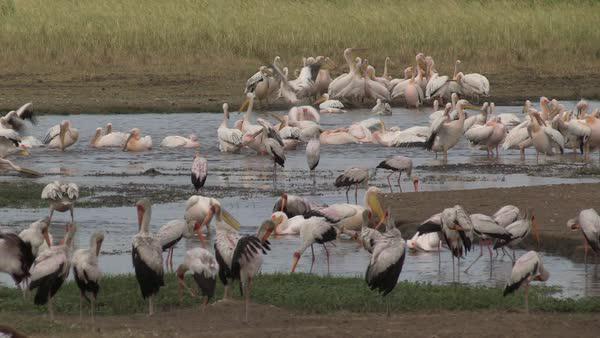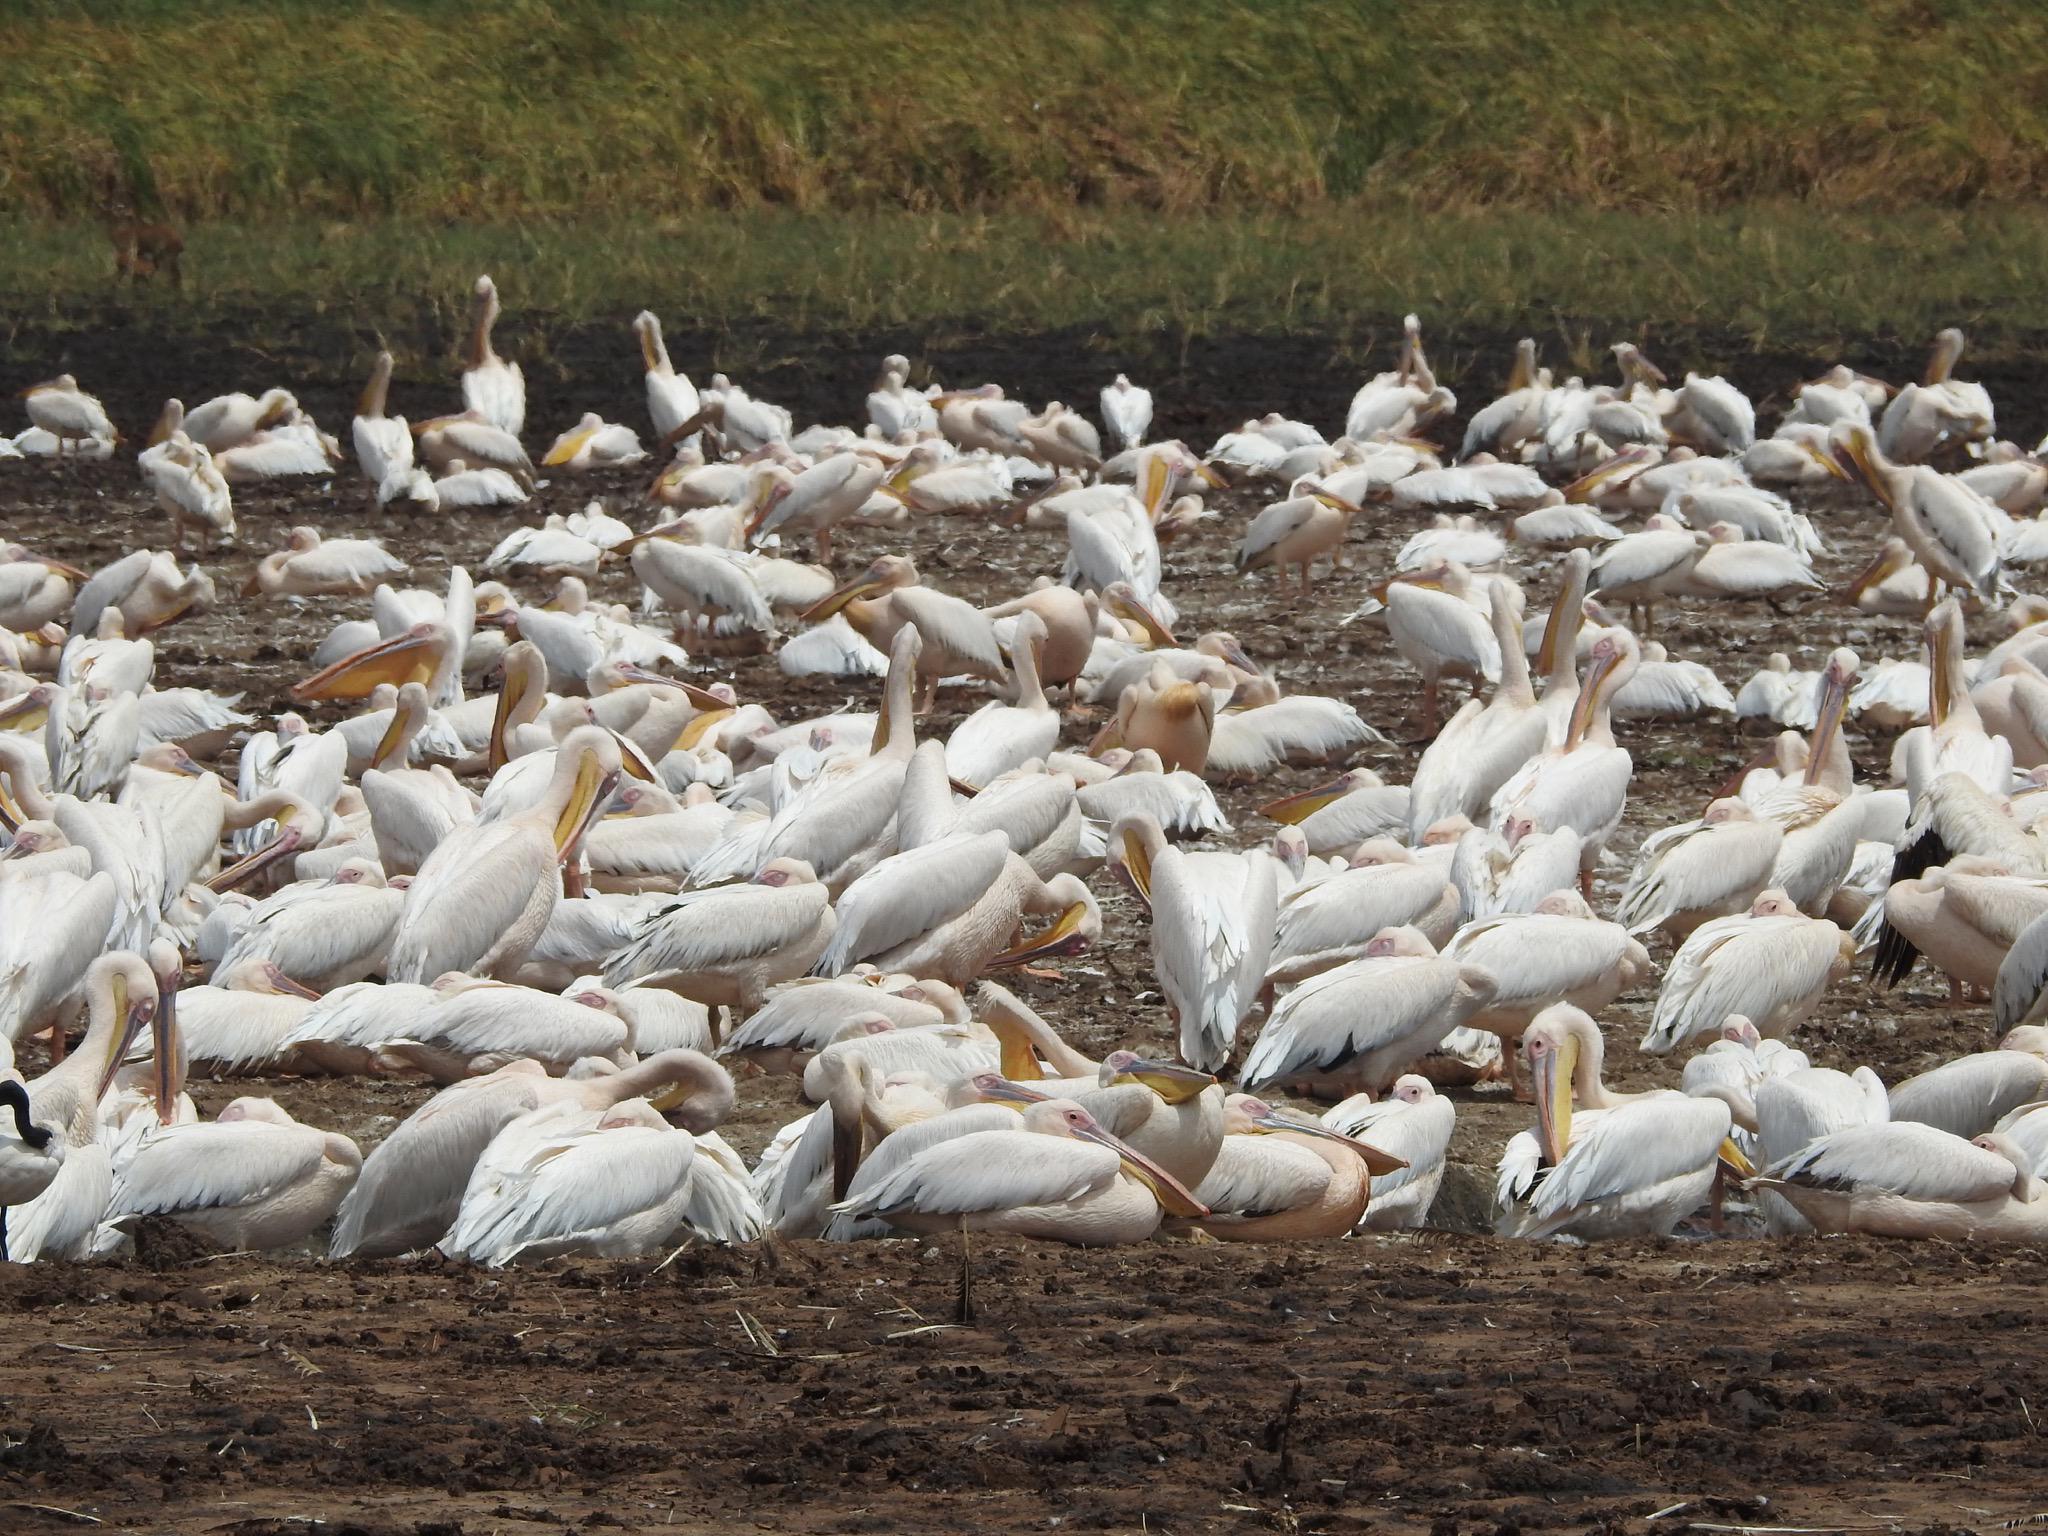The first image is the image on the left, the second image is the image on the right. For the images displayed, is the sentence "Birds are all in a group on an area of dry ground surrounded by water, in one image." factually correct? Answer yes or no. No. 